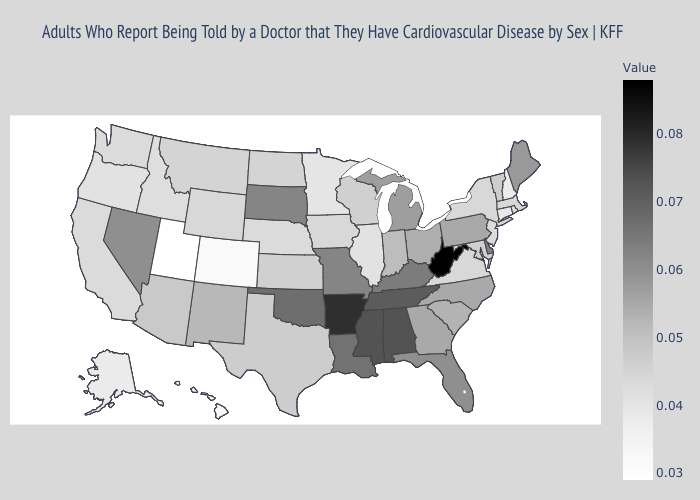Which states have the lowest value in the USA?
Be succinct. Utah. Does Pennsylvania have the lowest value in the Northeast?
Short answer required. No. 